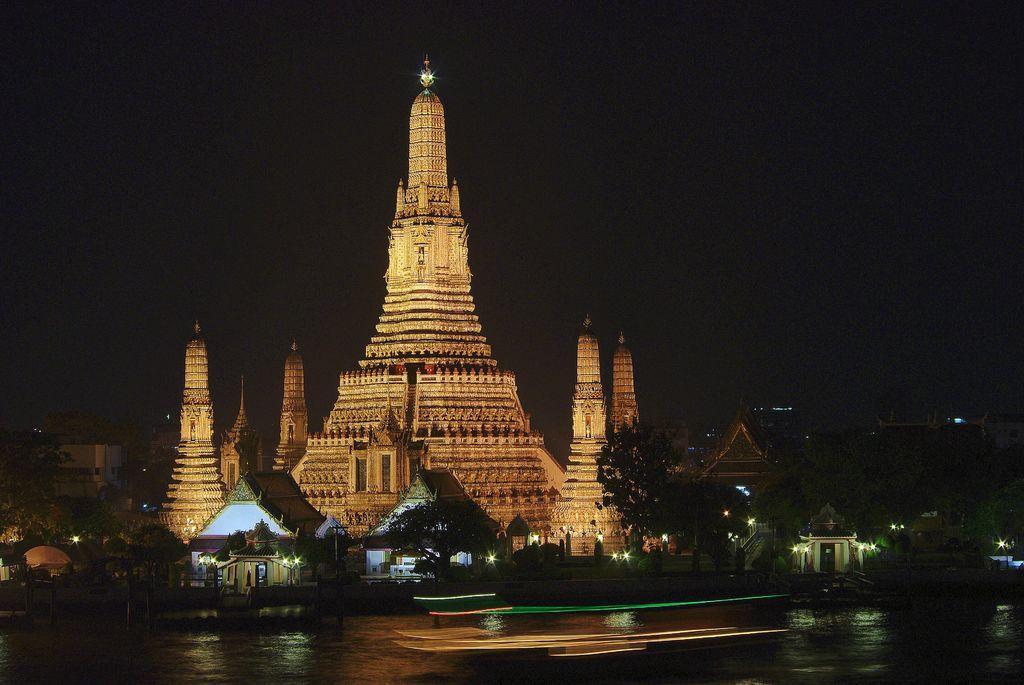Could you give a brief overview of what you see in this image? There is a building. Also there is water. On the sides of the water there are trees and small buildings. In the background it is dark. 